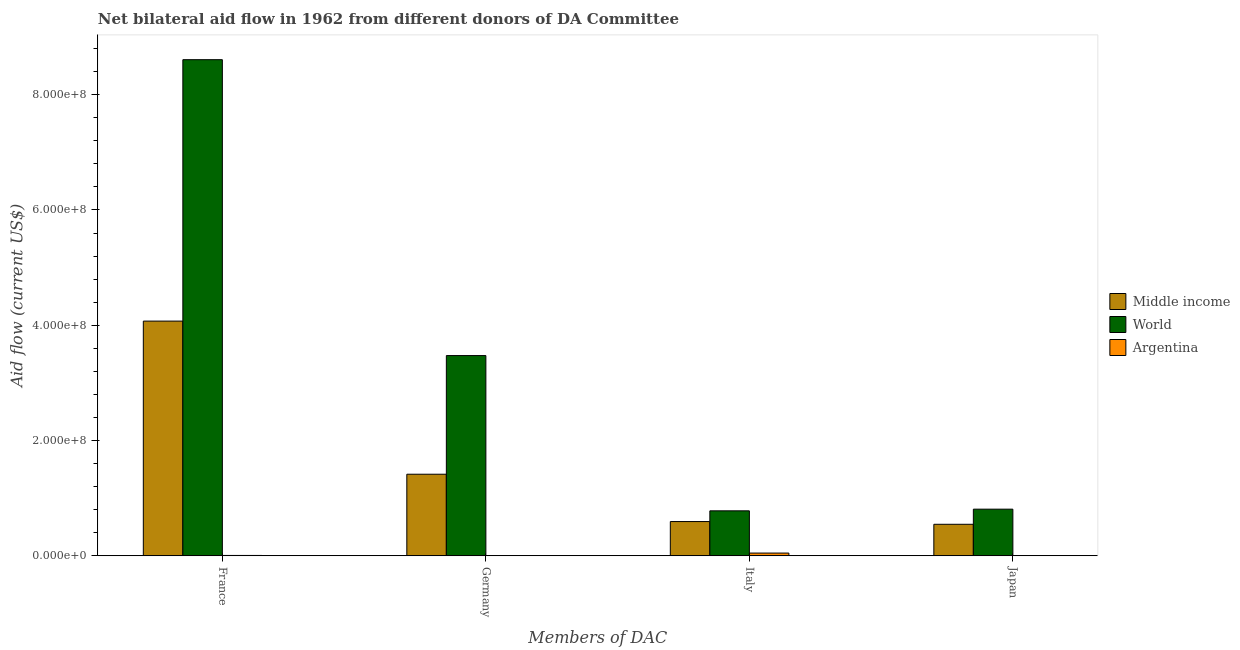How many different coloured bars are there?
Offer a terse response. 3. How many groups of bars are there?
Your response must be concise. 4. Are the number of bars on each tick of the X-axis equal?
Offer a very short reply. No. What is the amount of aid given by germany in World?
Your response must be concise. 3.47e+08. Across all countries, what is the maximum amount of aid given by italy?
Ensure brevity in your answer.  7.80e+07. What is the total amount of aid given by germany in the graph?
Give a very brief answer. 4.89e+08. What is the difference between the amount of aid given by italy in World and that in Argentina?
Make the answer very short. 7.33e+07. What is the difference between the amount of aid given by japan in Middle income and the amount of aid given by italy in Argentina?
Ensure brevity in your answer.  4.99e+07. What is the average amount of aid given by japan per country?
Give a very brief answer. 4.52e+07. What is the difference between the amount of aid given by japan and amount of aid given by germany in World?
Ensure brevity in your answer.  -2.67e+08. What is the ratio of the amount of aid given by germany in World to that in Middle income?
Your answer should be very brief. 2.45. Is the amount of aid given by france in Middle income less than that in World?
Your answer should be very brief. Yes. What is the difference between the highest and the second highest amount of aid given by france?
Offer a terse response. 4.54e+08. What is the difference between the highest and the lowest amount of aid given by germany?
Your answer should be very brief. 3.47e+08. In how many countries, is the amount of aid given by france greater than the average amount of aid given by france taken over all countries?
Keep it short and to the point. 1. Is the sum of the amount of aid given by france in Middle income and Argentina greater than the maximum amount of aid given by italy across all countries?
Keep it short and to the point. Yes. Is it the case that in every country, the sum of the amount of aid given by france and amount of aid given by italy is greater than the sum of amount of aid given by japan and amount of aid given by germany?
Provide a short and direct response. No. How many bars are there?
Offer a terse response. 10. Are all the bars in the graph horizontal?
Provide a succinct answer. No. What is the difference between two consecutive major ticks on the Y-axis?
Your response must be concise. 2.00e+08. Does the graph contain any zero values?
Provide a short and direct response. Yes. Does the graph contain grids?
Provide a succinct answer. No. How many legend labels are there?
Offer a terse response. 3. How are the legend labels stacked?
Offer a very short reply. Vertical. What is the title of the graph?
Provide a short and direct response. Net bilateral aid flow in 1962 from different donors of DA Committee. What is the label or title of the X-axis?
Provide a succinct answer. Members of DAC. What is the Aid flow (current US$) in Middle income in France?
Give a very brief answer. 4.07e+08. What is the Aid flow (current US$) in World in France?
Your answer should be compact. 8.61e+08. What is the Aid flow (current US$) of Argentina in France?
Provide a succinct answer. 6.00e+05. What is the Aid flow (current US$) of Middle income in Germany?
Your response must be concise. 1.42e+08. What is the Aid flow (current US$) in World in Germany?
Offer a terse response. 3.47e+08. What is the Aid flow (current US$) of Argentina in Germany?
Offer a terse response. 0. What is the Aid flow (current US$) in Middle income in Italy?
Your answer should be compact. 5.94e+07. What is the Aid flow (current US$) in World in Italy?
Provide a short and direct response. 7.80e+07. What is the Aid flow (current US$) of Argentina in Italy?
Keep it short and to the point. 4.73e+06. What is the Aid flow (current US$) of Middle income in Japan?
Provide a short and direct response. 5.47e+07. What is the Aid flow (current US$) in World in Japan?
Offer a terse response. 8.09e+07. Across all Members of DAC, what is the maximum Aid flow (current US$) of Middle income?
Provide a succinct answer. 4.07e+08. Across all Members of DAC, what is the maximum Aid flow (current US$) of World?
Provide a succinct answer. 8.61e+08. Across all Members of DAC, what is the maximum Aid flow (current US$) in Argentina?
Your answer should be very brief. 4.73e+06. Across all Members of DAC, what is the minimum Aid flow (current US$) of Middle income?
Keep it short and to the point. 5.47e+07. Across all Members of DAC, what is the minimum Aid flow (current US$) in World?
Keep it short and to the point. 7.80e+07. What is the total Aid flow (current US$) in Middle income in the graph?
Offer a terse response. 6.63e+08. What is the total Aid flow (current US$) of World in the graph?
Provide a short and direct response. 1.37e+09. What is the total Aid flow (current US$) of Argentina in the graph?
Your response must be concise. 5.33e+06. What is the difference between the Aid flow (current US$) of Middle income in France and that in Germany?
Keep it short and to the point. 2.66e+08. What is the difference between the Aid flow (current US$) in World in France and that in Germany?
Your answer should be very brief. 5.13e+08. What is the difference between the Aid flow (current US$) of Middle income in France and that in Italy?
Your response must be concise. 3.48e+08. What is the difference between the Aid flow (current US$) in World in France and that in Italy?
Offer a very short reply. 7.83e+08. What is the difference between the Aid flow (current US$) of Argentina in France and that in Italy?
Give a very brief answer. -4.13e+06. What is the difference between the Aid flow (current US$) of Middle income in France and that in Japan?
Ensure brevity in your answer.  3.53e+08. What is the difference between the Aid flow (current US$) in World in France and that in Japan?
Give a very brief answer. 7.80e+08. What is the difference between the Aid flow (current US$) in Middle income in Germany and that in Italy?
Your answer should be compact. 8.21e+07. What is the difference between the Aid flow (current US$) of World in Germany and that in Italy?
Your answer should be very brief. 2.69e+08. What is the difference between the Aid flow (current US$) in Middle income in Germany and that in Japan?
Provide a succinct answer. 8.69e+07. What is the difference between the Aid flow (current US$) of World in Germany and that in Japan?
Provide a short and direct response. 2.67e+08. What is the difference between the Aid flow (current US$) of Middle income in Italy and that in Japan?
Your answer should be very brief. 4.75e+06. What is the difference between the Aid flow (current US$) in World in Italy and that in Japan?
Ensure brevity in your answer.  -2.90e+06. What is the difference between the Aid flow (current US$) in Middle income in France and the Aid flow (current US$) in World in Germany?
Your response must be concise. 5.98e+07. What is the difference between the Aid flow (current US$) of Middle income in France and the Aid flow (current US$) of World in Italy?
Give a very brief answer. 3.29e+08. What is the difference between the Aid flow (current US$) in Middle income in France and the Aid flow (current US$) in Argentina in Italy?
Offer a very short reply. 4.02e+08. What is the difference between the Aid flow (current US$) of World in France and the Aid flow (current US$) of Argentina in Italy?
Your answer should be compact. 8.56e+08. What is the difference between the Aid flow (current US$) of Middle income in France and the Aid flow (current US$) of World in Japan?
Give a very brief answer. 3.26e+08. What is the difference between the Aid flow (current US$) of Middle income in Germany and the Aid flow (current US$) of World in Italy?
Keep it short and to the point. 6.35e+07. What is the difference between the Aid flow (current US$) of Middle income in Germany and the Aid flow (current US$) of Argentina in Italy?
Your response must be concise. 1.37e+08. What is the difference between the Aid flow (current US$) in World in Germany and the Aid flow (current US$) in Argentina in Italy?
Keep it short and to the point. 3.43e+08. What is the difference between the Aid flow (current US$) in Middle income in Germany and the Aid flow (current US$) in World in Japan?
Offer a terse response. 6.06e+07. What is the difference between the Aid flow (current US$) in Middle income in Italy and the Aid flow (current US$) in World in Japan?
Your answer should be very brief. -2.15e+07. What is the average Aid flow (current US$) of Middle income per Members of DAC?
Keep it short and to the point. 1.66e+08. What is the average Aid flow (current US$) of World per Members of DAC?
Ensure brevity in your answer.  3.42e+08. What is the average Aid flow (current US$) of Argentina per Members of DAC?
Your response must be concise. 1.33e+06. What is the difference between the Aid flow (current US$) in Middle income and Aid flow (current US$) in World in France?
Provide a short and direct response. -4.54e+08. What is the difference between the Aid flow (current US$) of Middle income and Aid flow (current US$) of Argentina in France?
Offer a very short reply. 4.07e+08. What is the difference between the Aid flow (current US$) in World and Aid flow (current US$) in Argentina in France?
Make the answer very short. 8.60e+08. What is the difference between the Aid flow (current US$) in Middle income and Aid flow (current US$) in World in Germany?
Provide a short and direct response. -2.06e+08. What is the difference between the Aid flow (current US$) in Middle income and Aid flow (current US$) in World in Italy?
Make the answer very short. -1.86e+07. What is the difference between the Aid flow (current US$) in Middle income and Aid flow (current US$) in Argentina in Italy?
Give a very brief answer. 5.47e+07. What is the difference between the Aid flow (current US$) in World and Aid flow (current US$) in Argentina in Italy?
Provide a short and direct response. 7.33e+07. What is the difference between the Aid flow (current US$) of Middle income and Aid flow (current US$) of World in Japan?
Your answer should be very brief. -2.62e+07. What is the ratio of the Aid flow (current US$) in Middle income in France to that in Germany?
Keep it short and to the point. 2.88. What is the ratio of the Aid flow (current US$) of World in France to that in Germany?
Keep it short and to the point. 2.48. What is the ratio of the Aid flow (current US$) of Middle income in France to that in Italy?
Keep it short and to the point. 6.85. What is the ratio of the Aid flow (current US$) of World in France to that in Italy?
Keep it short and to the point. 11.04. What is the ratio of the Aid flow (current US$) of Argentina in France to that in Italy?
Offer a terse response. 0.13. What is the ratio of the Aid flow (current US$) in Middle income in France to that in Japan?
Offer a terse response. 7.45. What is the ratio of the Aid flow (current US$) of World in France to that in Japan?
Make the answer very short. 10.64. What is the ratio of the Aid flow (current US$) of Middle income in Germany to that in Italy?
Provide a succinct answer. 2.38. What is the ratio of the Aid flow (current US$) of World in Germany to that in Italy?
Offer a terse response. 4.45. What is the ratio of the Aid flow (current US$) of Middle income in Germany to that in Japan?
Your response must be concise. 2.59. What is the ratio of the Aid flow (current US$) in World in Germany to that in Japan?
Keep it short and to the point. 4.29. What is the ratio of the Aid flow (current US$) in Middle income in Italy to that in Japan?
Your answer should be compact. 1.09. What is the ratio of the Aid flow (current US$) in World in Italy to that in Japan?
Offer a terse response. 0.96. What is the difference between the highest and the second highest Aid flow (current US$) in Middle income?
Provide a succinct answer. 2.66e+08. What is the difference between the highest and the second highest Aid flow (current US$) of World?
Give a very brief answer. 5.13e+08. What is the difference between the highest and the lowest Aid flow (current US$) of Middle income?
Ensure brevity in your answer.  3.53e+08. What is the difference between the highest and the lowest Aid flow (current US$) in World?
Your answer should be compact. 7.83e+08. What is the difference between the highest and the lowest Aid flow (current US$) in Argentina?
Provide a succinct answer. 4.73e+06. 